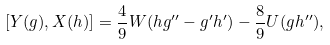Convert formula to latex. <formula><loc_0><loc_0><loc_500><loc_500>\left [ Y ( g ) , X ( h ) \right ] = \frac { 4 } { 9 } W ( h g { ^ { \prime \prime } } - g ^ { \prime } h ^ { \prime } ) - \frac { 8 } { 9 } U ( g h { ^ { \prime \prime } } ) ,</formula> 